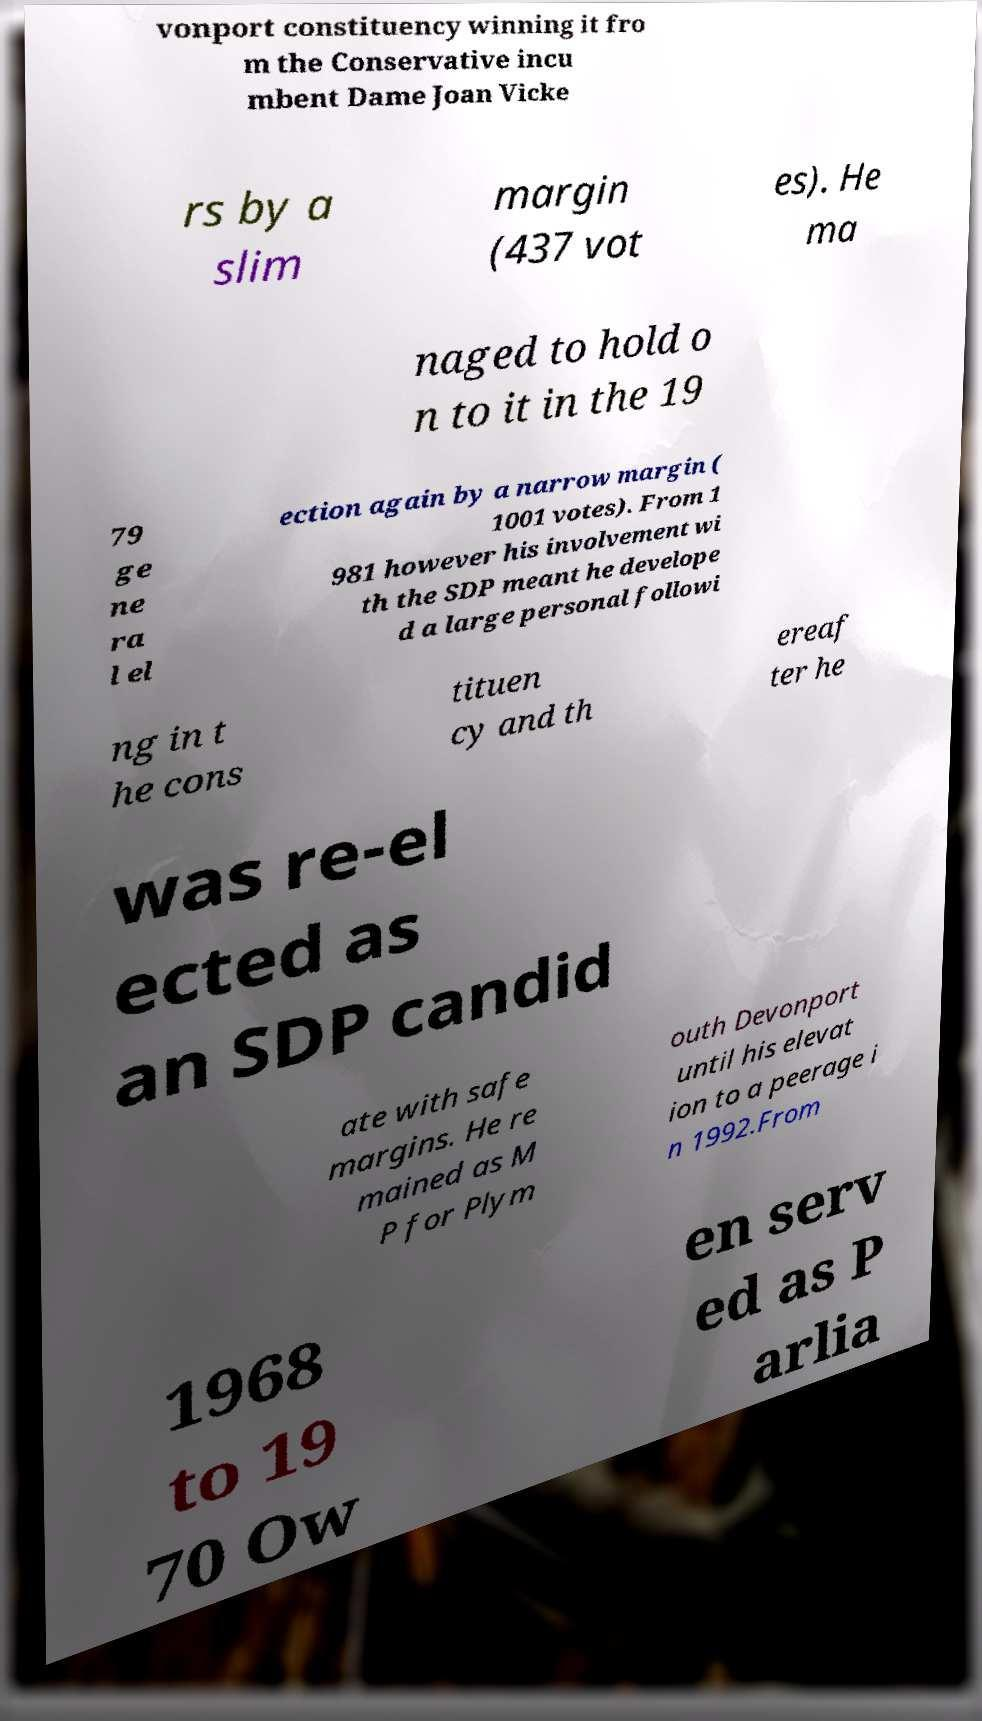Could you extract and type out the text from this image? vonport constituency winning it fro m the Conservative incu mbent Dame Joan Vicke rs by a slim margin (437 vot es). He ma naged to hold o n to it in the 19 79 ge ne ra l el ection again by a narrow margin ( 1001 votes). From 1 981 however his involvement wi th the SDP meant he develope d a large personal followi ng in t he cons tituen cy and th ereaf ter he was re-el ected as an SDP candid ate with safe margins. He re mained as M P for Plym outh Devonport until his elevat ion to a peerage i n 1992.From 1968 to 19 70 Ow en serv ed as P arlia 